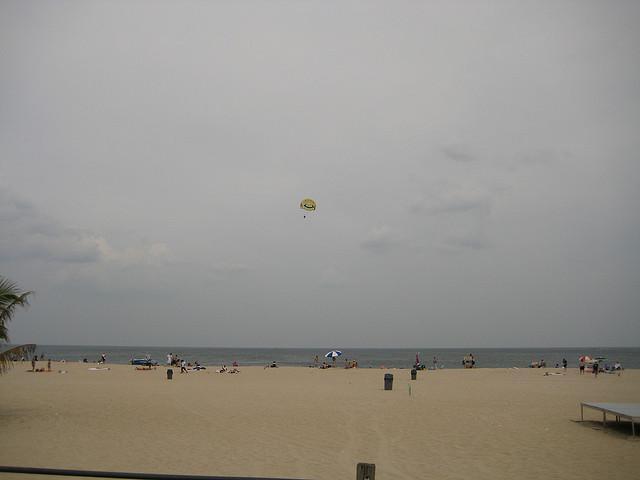How many scenes are in the image?
Give a very brief answer. 1. How many umbrellas are there?
Give a very brief answer. 2. How many umbrella's are shown?
Give a very brief answer. 2. How many parasailers are there?
Give a very brief answer. 1. 